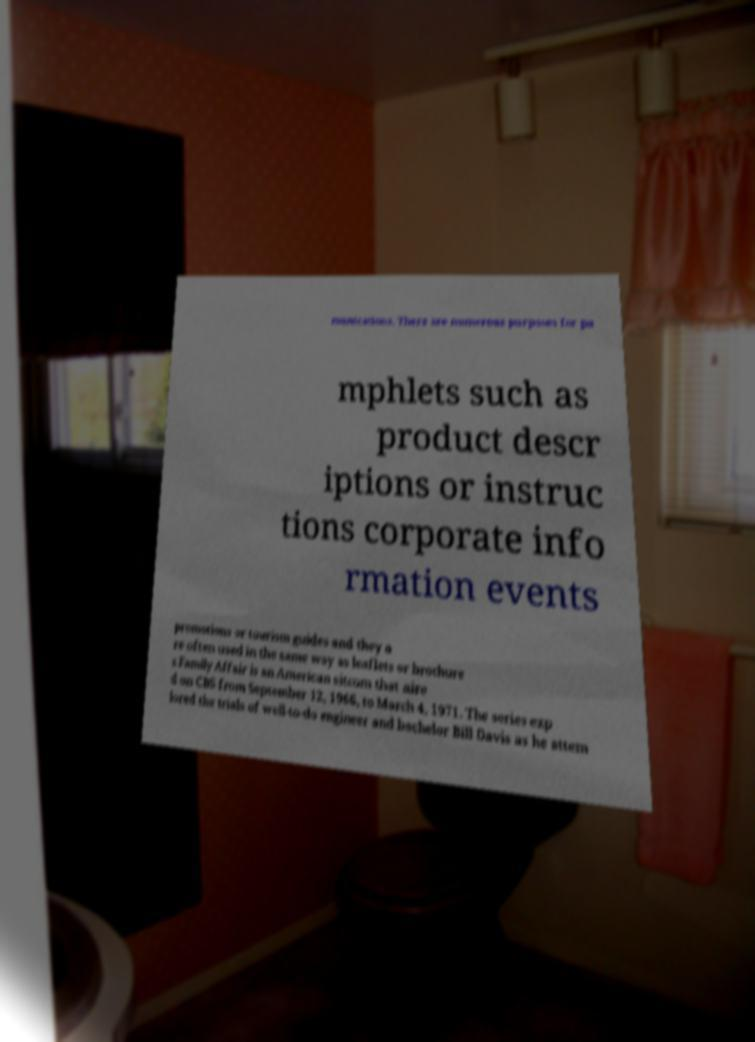For documentation purposes, I need the text within this image transcribed. Could you provide that? munications. There are numerous purposes for pa mphlets such as product descr iptions or instruc tions corporate info rmation events promotions or tourism guides and they a re often used in the same way as leaflets or brochure s.Family Affair is an American sitcom that aire d on CBS from September 12, 1966, to March 4, 1971. The series exp lored the trials of well-to-do engineer and bachelor Bill Davis as he attem 